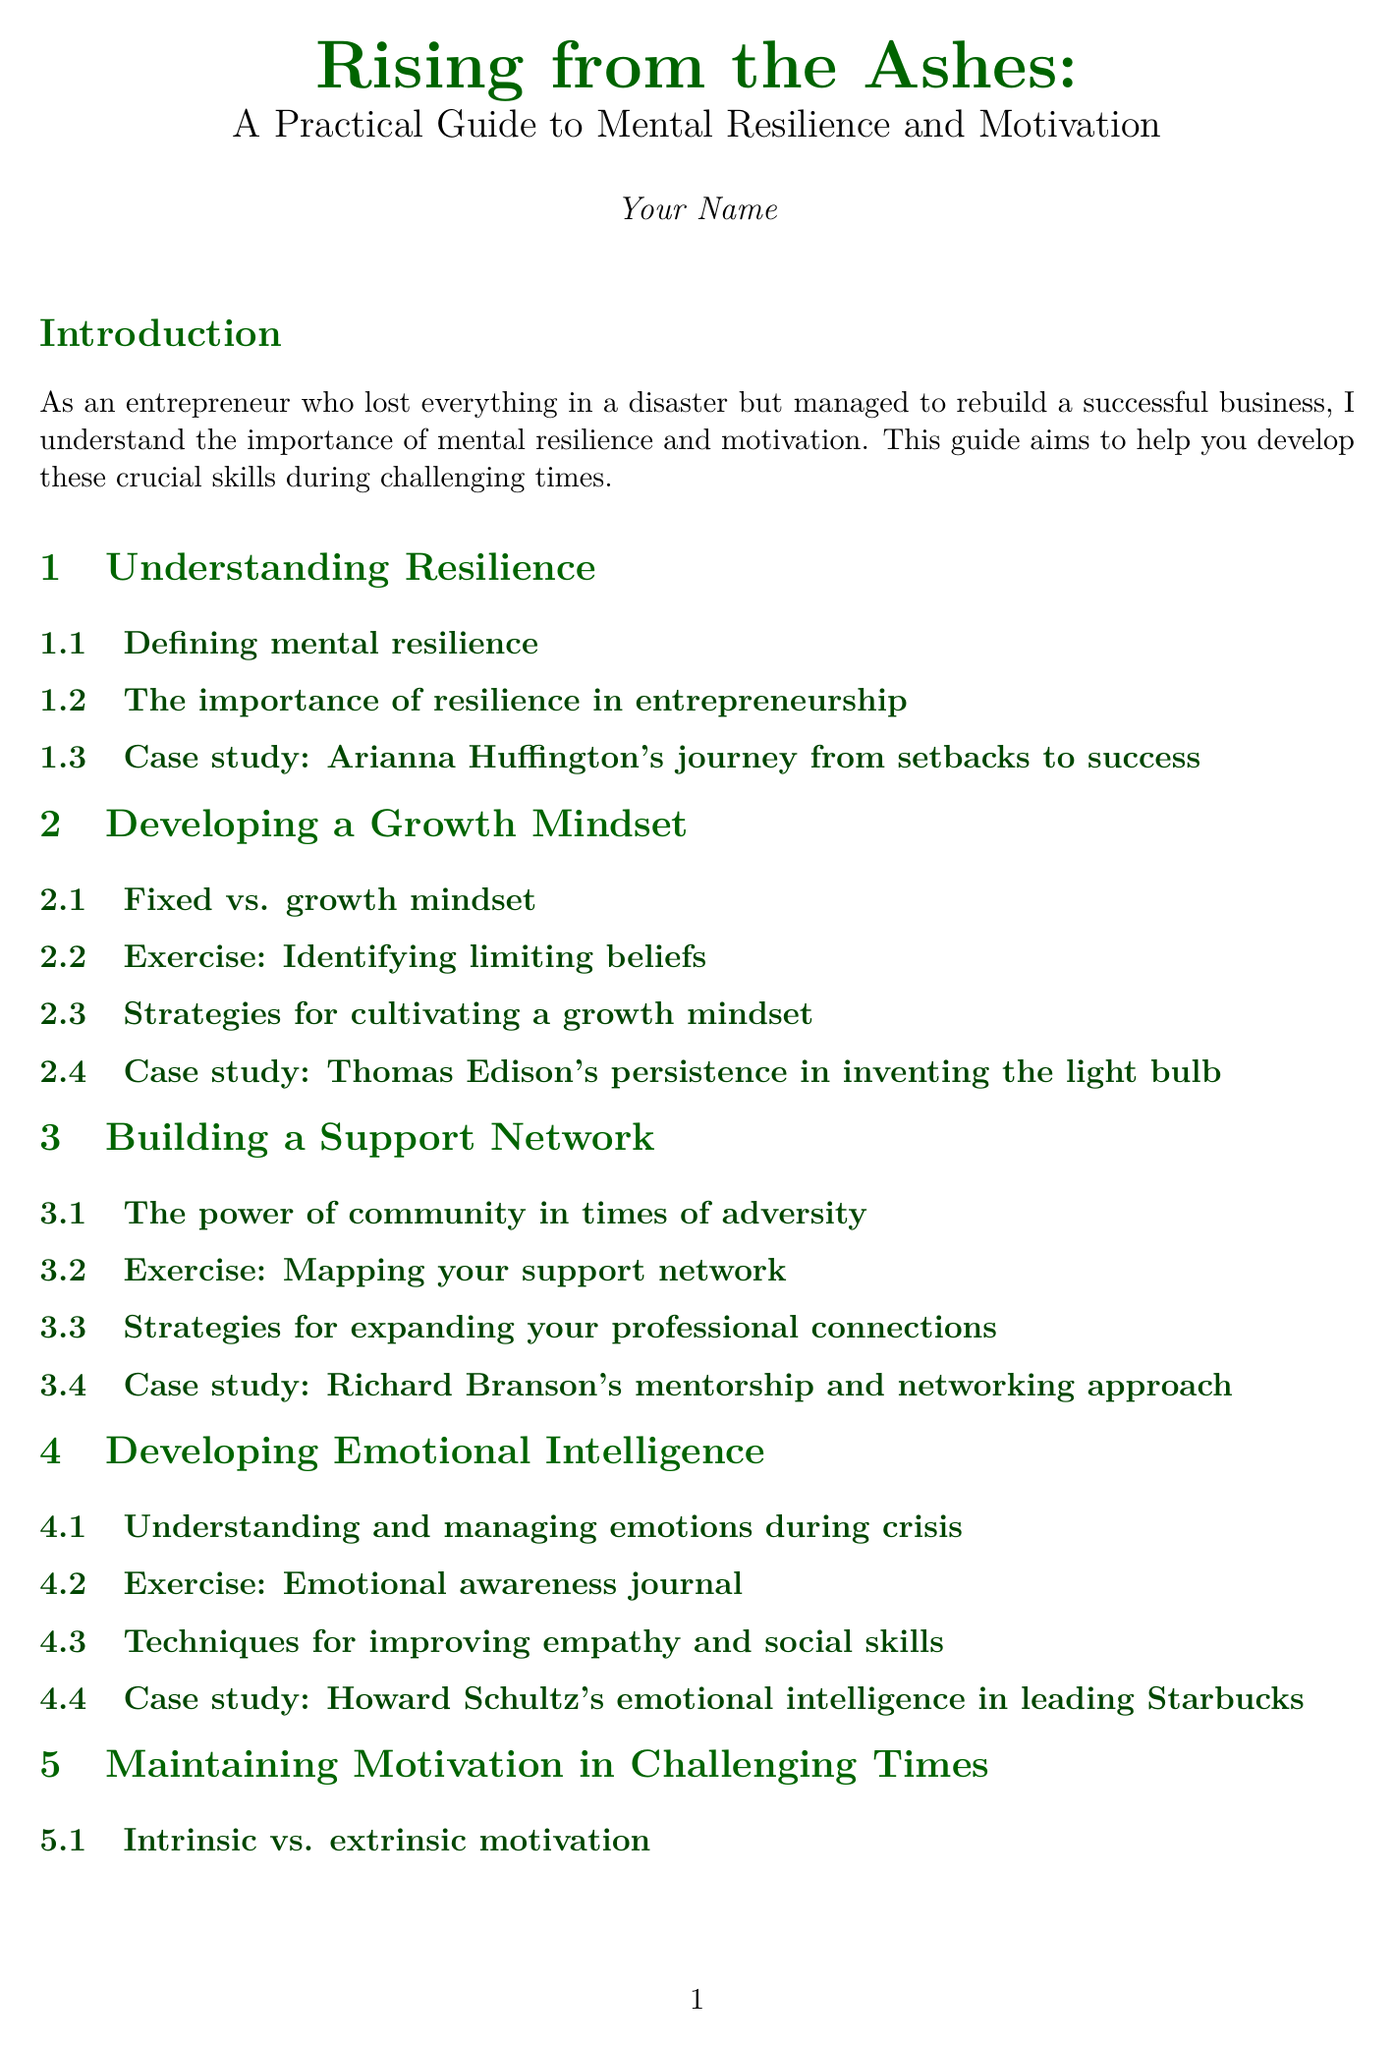what is the title of the handbook? The title of the handbook is mentioned in the introduction section of the document.
Answer: Rising from the Ashes: A Practical Guide to Mental Resilience and Motivation who is the author of the handbook? The author's name is provided at the beginning of the document.
Answer: Your Name what is the first chapter titled? The chapters are listed in the document, with the first one being included in the sections.
Answer: Understanding Resilience how many sections are in the chapter on "Building a Support Network"? Each chapter consists of multiple sections, counted in the corresponding chapter segment.
Answer: Four which case study is mentioned under the "Embracing Failure as a Learning Opportunity" chapter? The case studies are referenced in their respective chapters to illustrate key concepts.
Answer: Steve Jobs' comeback after being fired from Apple what type of exercise is included in the chapter on "Maintaining Motivation in Challenging Times"? Exercises are specifically identified in each chapter, showcasing practical applications.
Answer: Identifying your core values and purpose what framework is discussed in the "Goal Setting and Action Planning" chapter? The document outlines a specific framework for goal setting in this chapter.
Answer: SMART goal setting framework which famous entrepreneur's journey is highlighted in the chapter on "Financial Resilience"? case studies are used to exemplify financial strategies, including notable figures.
Answer: Mark Cuban's approach to financial preparedness what is the purpose of the handbook as stated in the introduction? The purpose is outlined clearly in the introduction, serving as the handbook's goal.
Answer: To help others develop mental resilience and maintain motivation during challenging times 